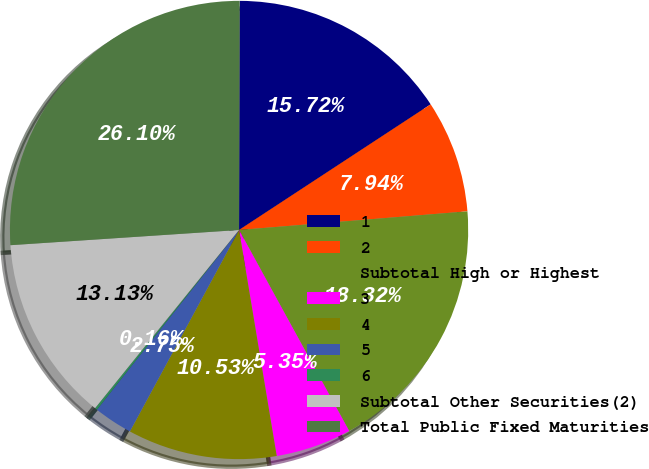<chart> <loc_0><loc_0><loc_500><loc_500><pie_chart><fcel>1<fcel>2<fcel>Subtotal High or Highest<fcel>3<fcel>4<fcel>5<fcel>6<fcel>Subtotal Other Securities(2)<fcel>Total Public Fixed Maturities<nl><fcel>15.72%<fcel>7.94%<fcel>18.32%<fcel>5.35%<fcel>10.53%<fcel>2.75%<fcel>0.16%<fcel>13.13%<fcel>26.1%<nl></chart> 